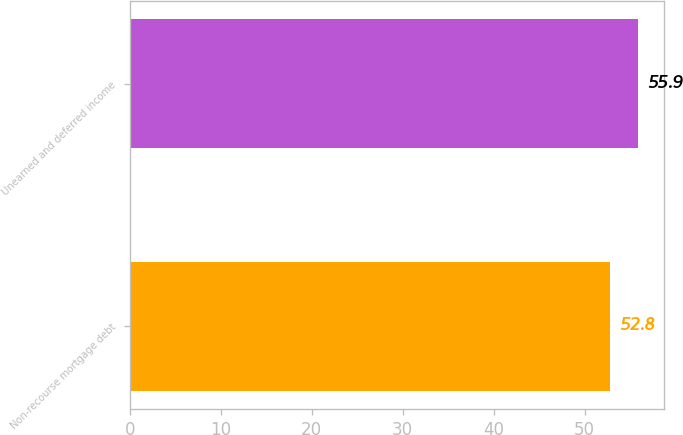Convert chart. <chart><loc_0><loc_0><loc_500><loc_500><bar_chart><fcel>Non-recourse mortgage debt<fcel>Unearned and deferred income<nl><fcel>52.8<fcel>55.9<nl></chart> 